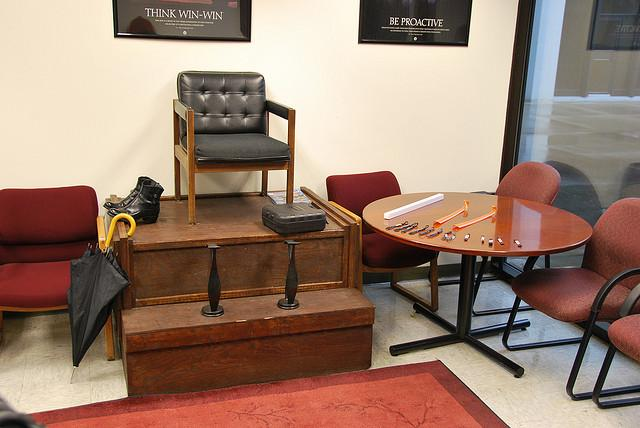What activity goes on in the chair on the platform? shoe shining 